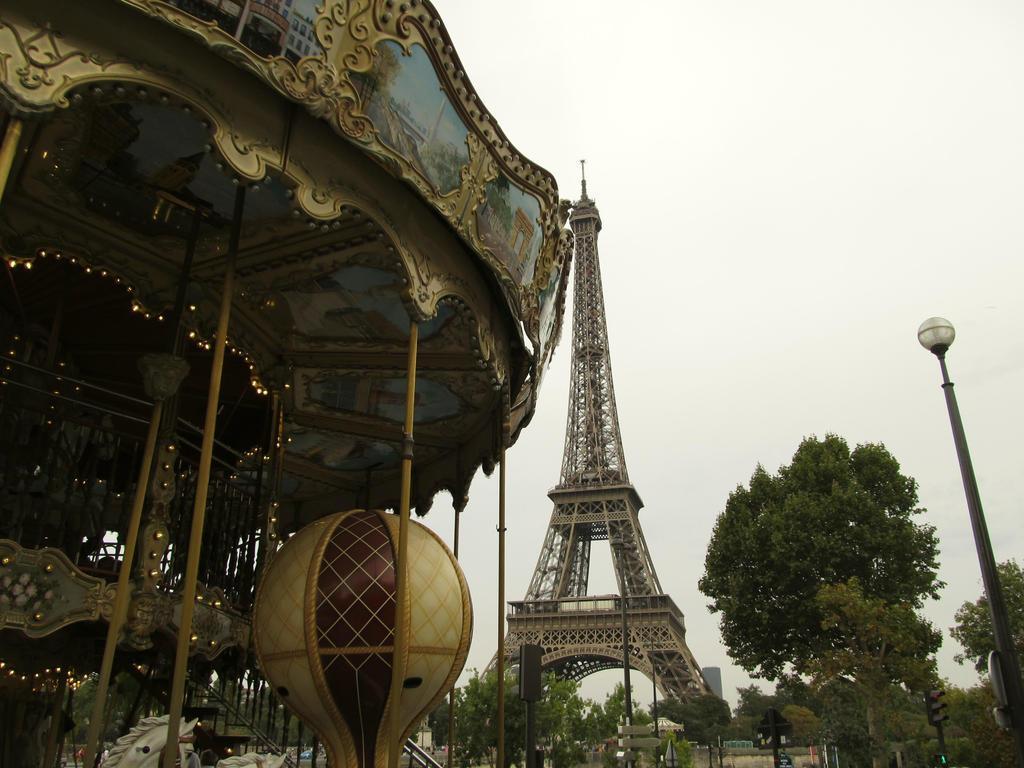Describe this image in one or two sentences. On the left side of the image there is a carousel. On the right side we can see light and trees. In the background there is a tower, buildings, trees and sky. 